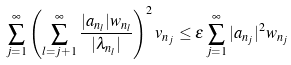Convert formula to latex. <formula><loc_0><loc_0><loc_500><loc_500>\sum _ { j = 1 } ^ { \infty } \left ( \sum _ { l = j + 1 } ^ { \infty } \frac { | a _ { n _ { l } } | w _ { n _ { l } } } { | \lambda _ { n _ { l } } | } \right ) ^ { 2 } v _ { n _ { j } } \leq \varepsilon \sum _ { j = 1 } ^ { \infty } | a _ { n _ { j } } | ^ { 2 } w _ { n _ { j } }</formula> 